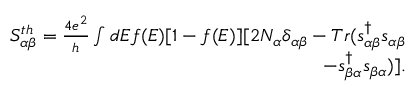<formula> <loc_0><loc_0><loc_500><loc_500>\begin{array} { r } { { S _ { \alpha \beta } ^ { t h } } = \frac { 4 e ^ { 2 } } { h } \int d E f ( E ) [ 1 - f ( E ) ] [ 2 N _ { \alpha } \delta _ { \alpha \beta } - T r ( s _ { \alpha \beta } ^ { \dagger } s _ { \alpha \beta } } \\ { - s _ { \beta \alpha } ^ { \dagger } s _ { \beta \alpha } ) ] . } \end{array}</formula> 